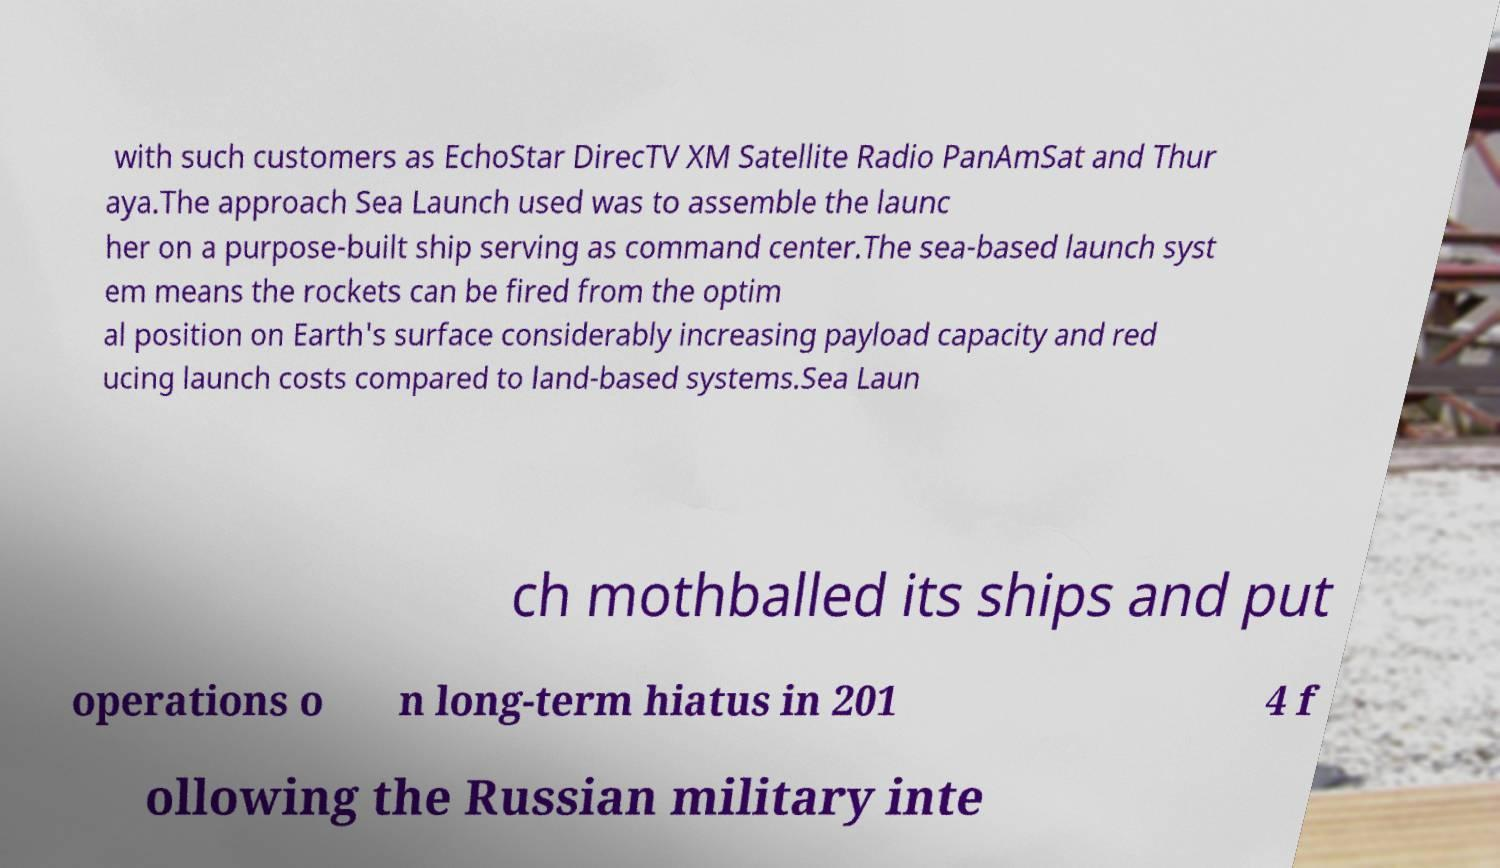Please read and relay the text visible in this image. What does it say? with such customers as EchoStar DirecTV XM Satellite Radio PanAmSat and Thur aya.The approach Sea Launch used was to assemble the launc her on a purpose-built ship serving as command center.The sea-based launch syst em means the rockets can be fired from the optim al position on Earth's surface considerably increasing payload capacity and red ucing launch costs compared to land-based systems.Sea Laun ch mothballed its ships and put operations o n long-term hiatus in 201 4 f ollowing the Russian military inte 